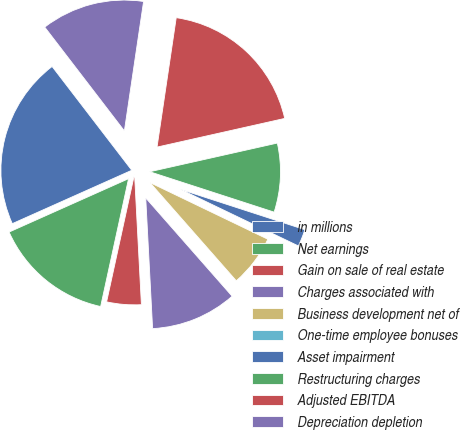<chart> <loc_0><loc_0><loc_500><loc_500><pie_chart><fcel>in millions<fcel>Net earnings<fcel>Gain on sale of real estate<fcel>Charges associated with<fcel>Business development net of<fcel>One-time employee bonuses<fcel>Asset impairment<fcel>Restructuring charges<fcel>Adjusted EBITDA<fcel>Depreciation depletion<nl><fcel>21.27%<fcel>14.89%<fcel>4.26%<fcel>10.64%<fcel>6.39%<fcel>0.01%<fcel>2.13%<fcel>8.51%<fcel>19.14%<fcel>12.76%<nl></chart> 